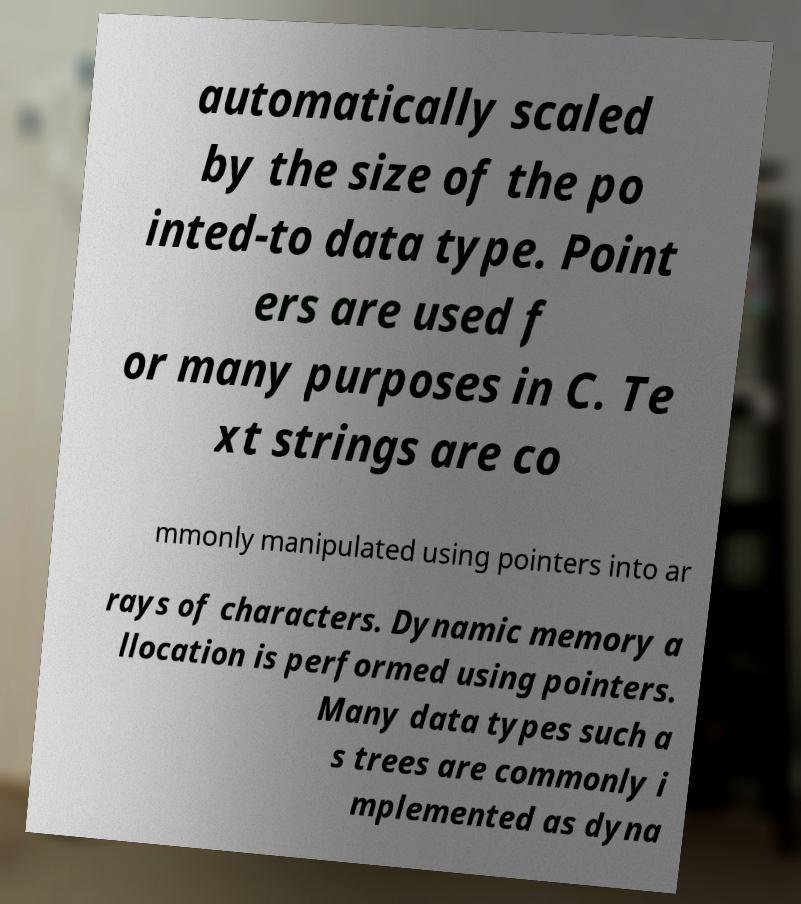Can you read and provide the text displayed in the image?This photo seems to have some interesting text. Can you extract and type it out for me? automatically scaled by the size of the po inted-to data type. Point ers are used f or many purposes in C. Te xt strings are co mmonly manipulated using pointers into ar rays of characters. Dynamic memory a llocation is performed using pointers. Many data types such a s trees are commonly i mplemented as dyna 